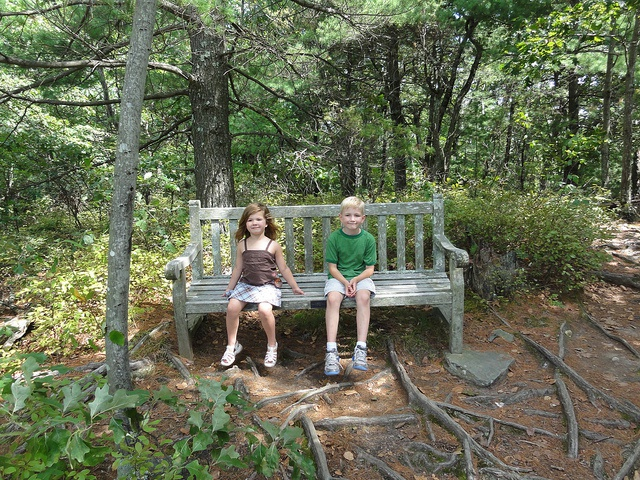Describe the objects in this image and their specific colors. I can see bench in lightgreen, darkgray, gray, and lightgray tones, people in lightgreen, white, gray, and darkgray tones, and people in lightgreen, tan, lightgray, darkgray, and darkgreen tones in this image. 